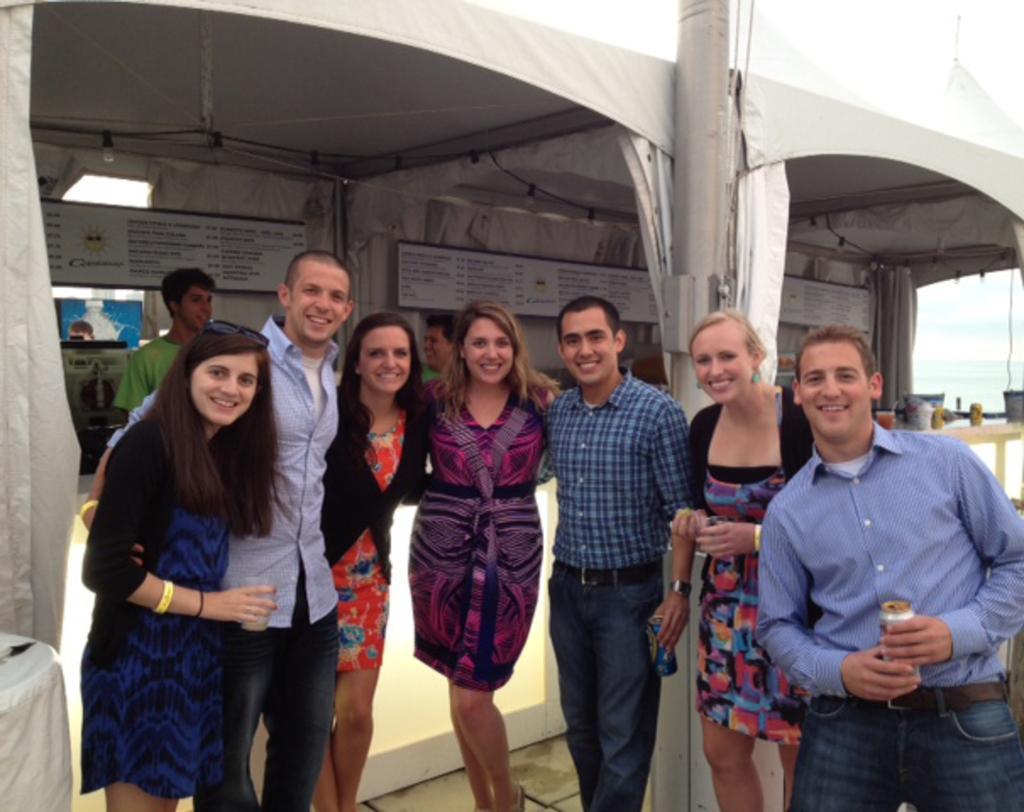Could you give a brief overview of what you see in this image? This picture describes about group of people, on the middle of the given image we can see few people, they are smiling, on the right side of the given image we can find a man, he is holding a tin in his hand, in the background we can find few cables. 